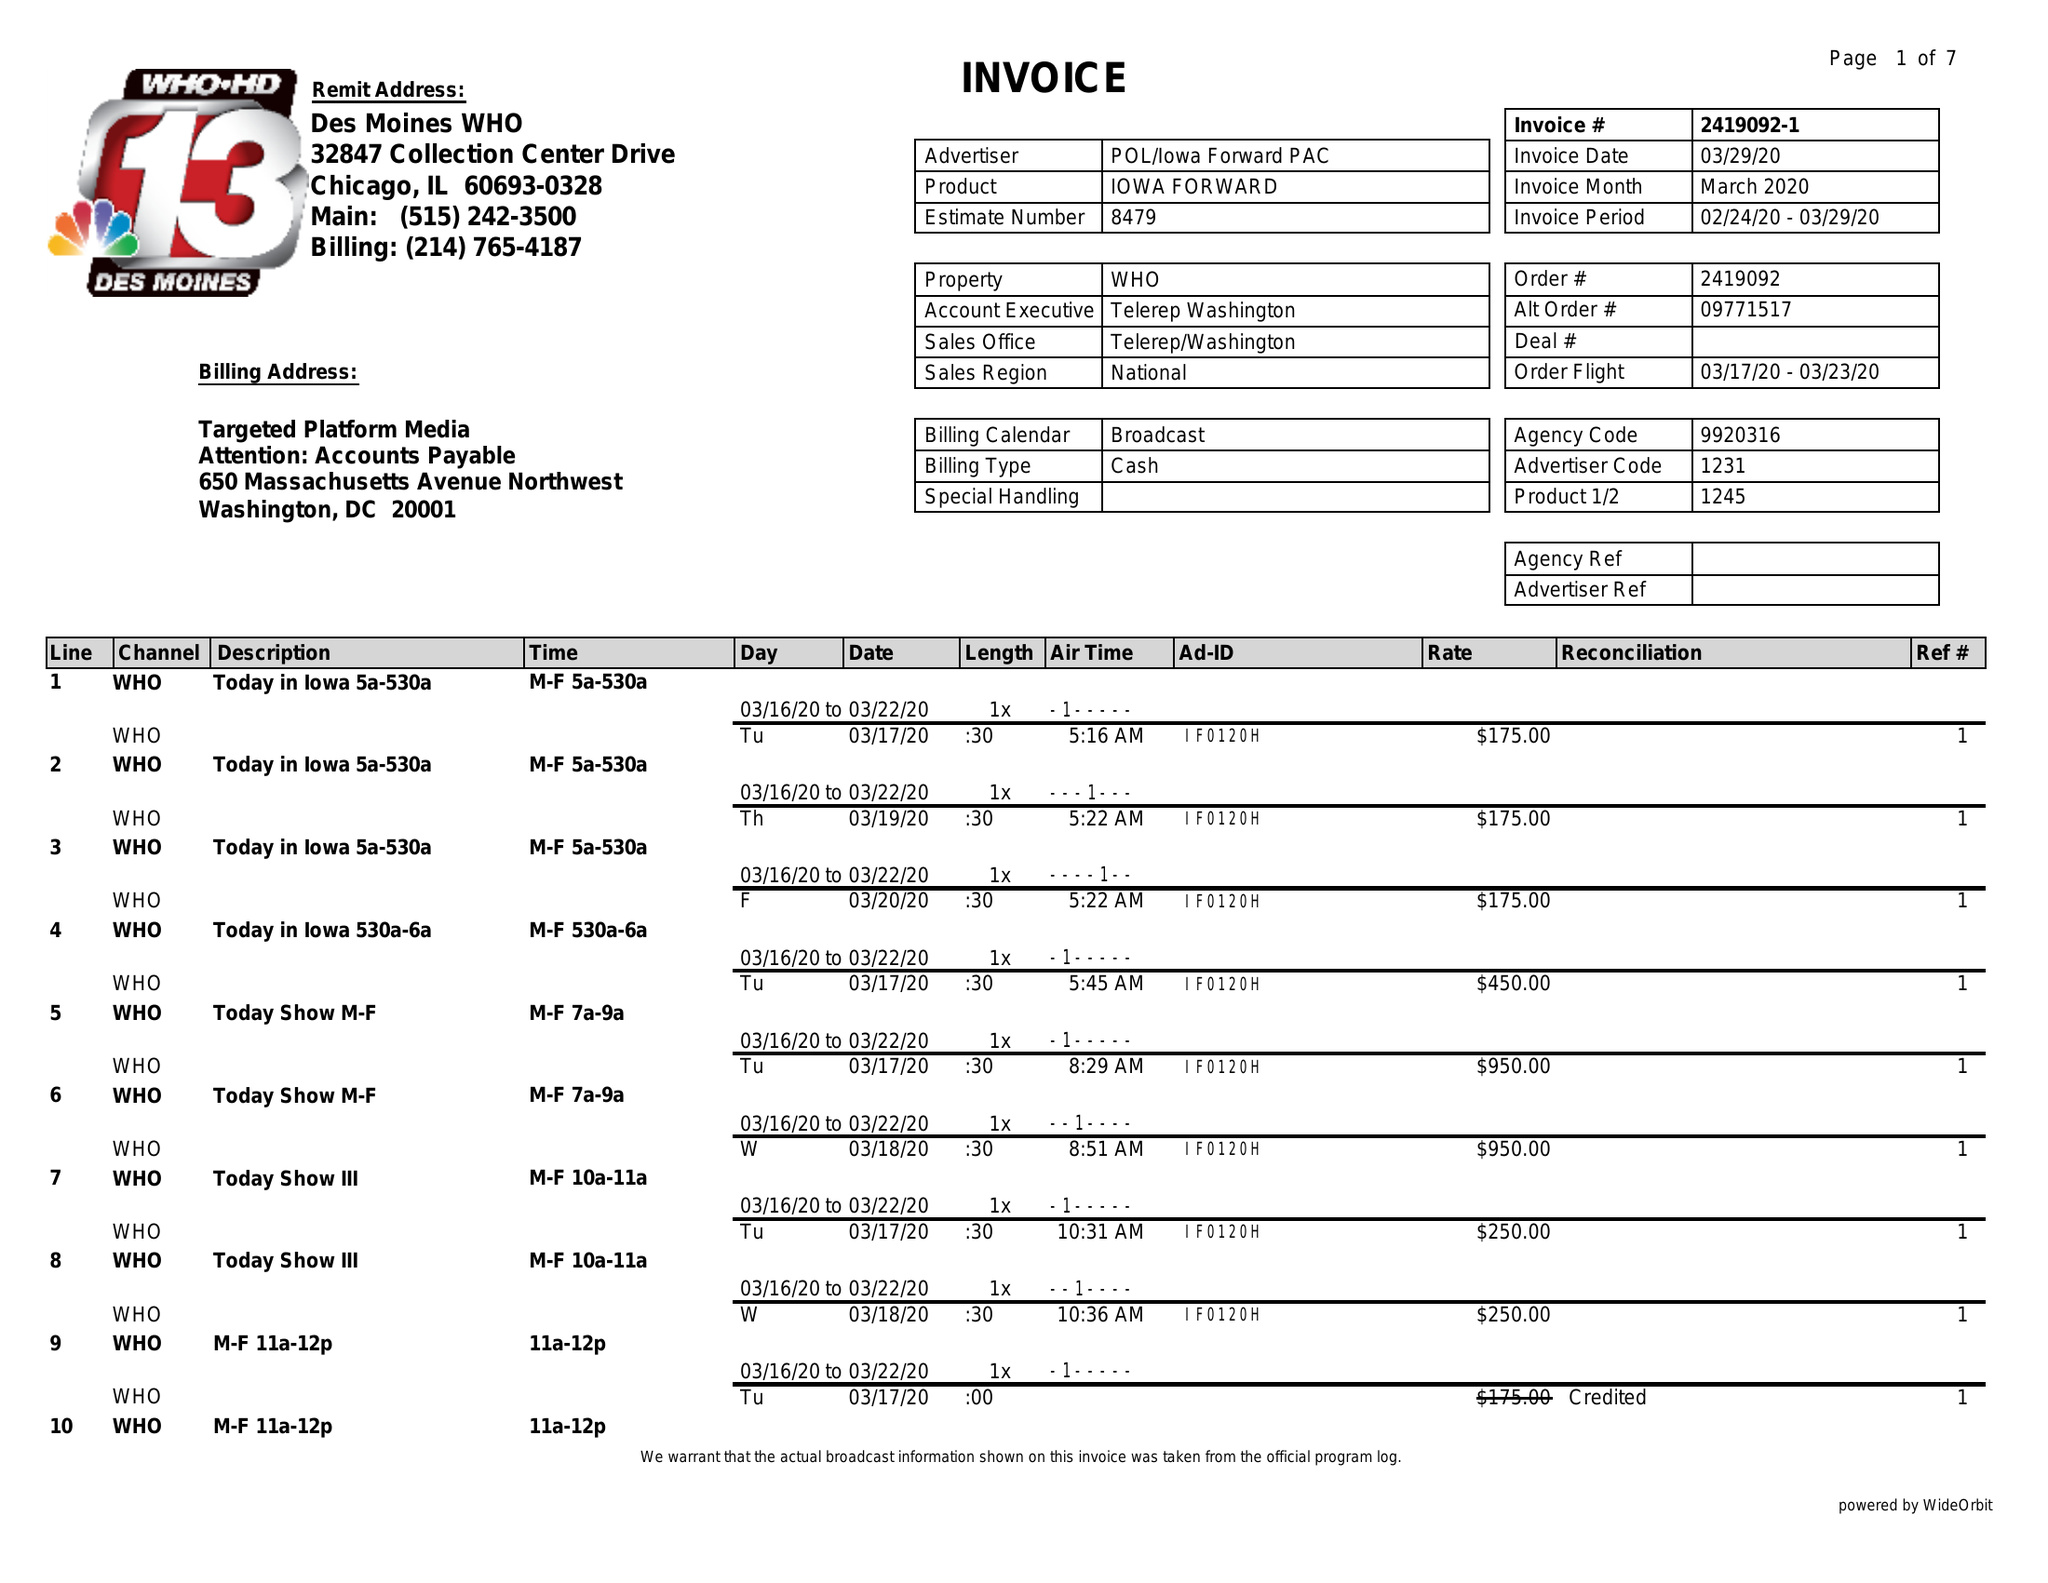What is the value for the gross_amount?
Answer the question using a single word or phrase. 32075.00 